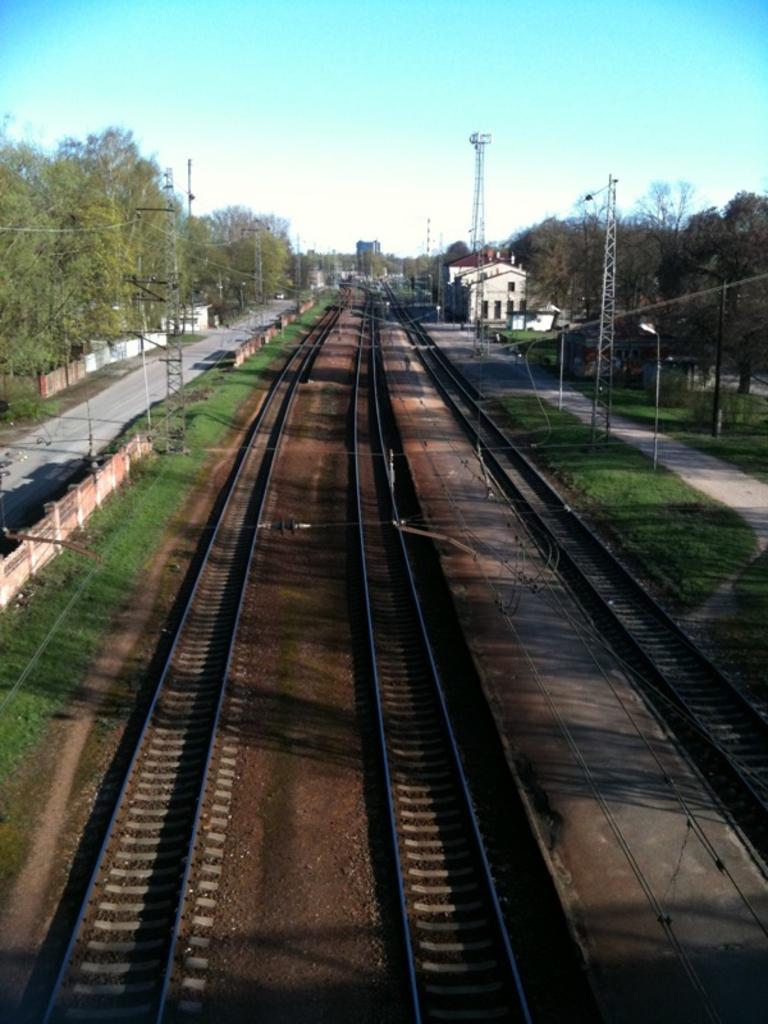How would you summarize this image in a sentence or two? In this image I can see few trees,railway tracks,fencing,towers and light poles. The sky is in white and blue color. 